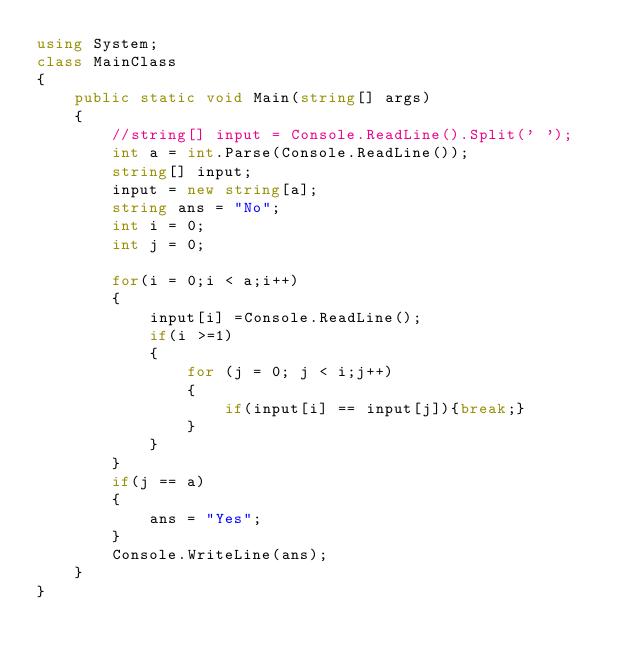<code> <loc_0><loc_0><loc_500><loc_500><_C#_>using System;
class MainClass
{
    public static void Main(string[] args)
    {
        //string[] input = Console.ReadLine().Split(' ');
        int a = int.Parse(Console.ReadLine());
        string[] input;
        input = new string[a];
        string ans = "No";
        int i = 0;
        int j = 0;

        for(i = 0;i < a;i++)
        {
            input[i] =Console.ReadLine();
            if(i >=1)
            {
                for (j = 0; j < i;j++)
                {
                    if(input[i] == input[j]){break;}
                }
            }
        }
        if(j == a)
        {
            ans = "Yes";
        }
        Console.WriteLine(ans);
    }
}
</code> 